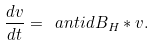Convert formula to latex. <formula><loc_0><loc_0><loc_500><loc_500>\frac { d v } { d t } = \ a n t i d B _ { H } * v .</formula> 